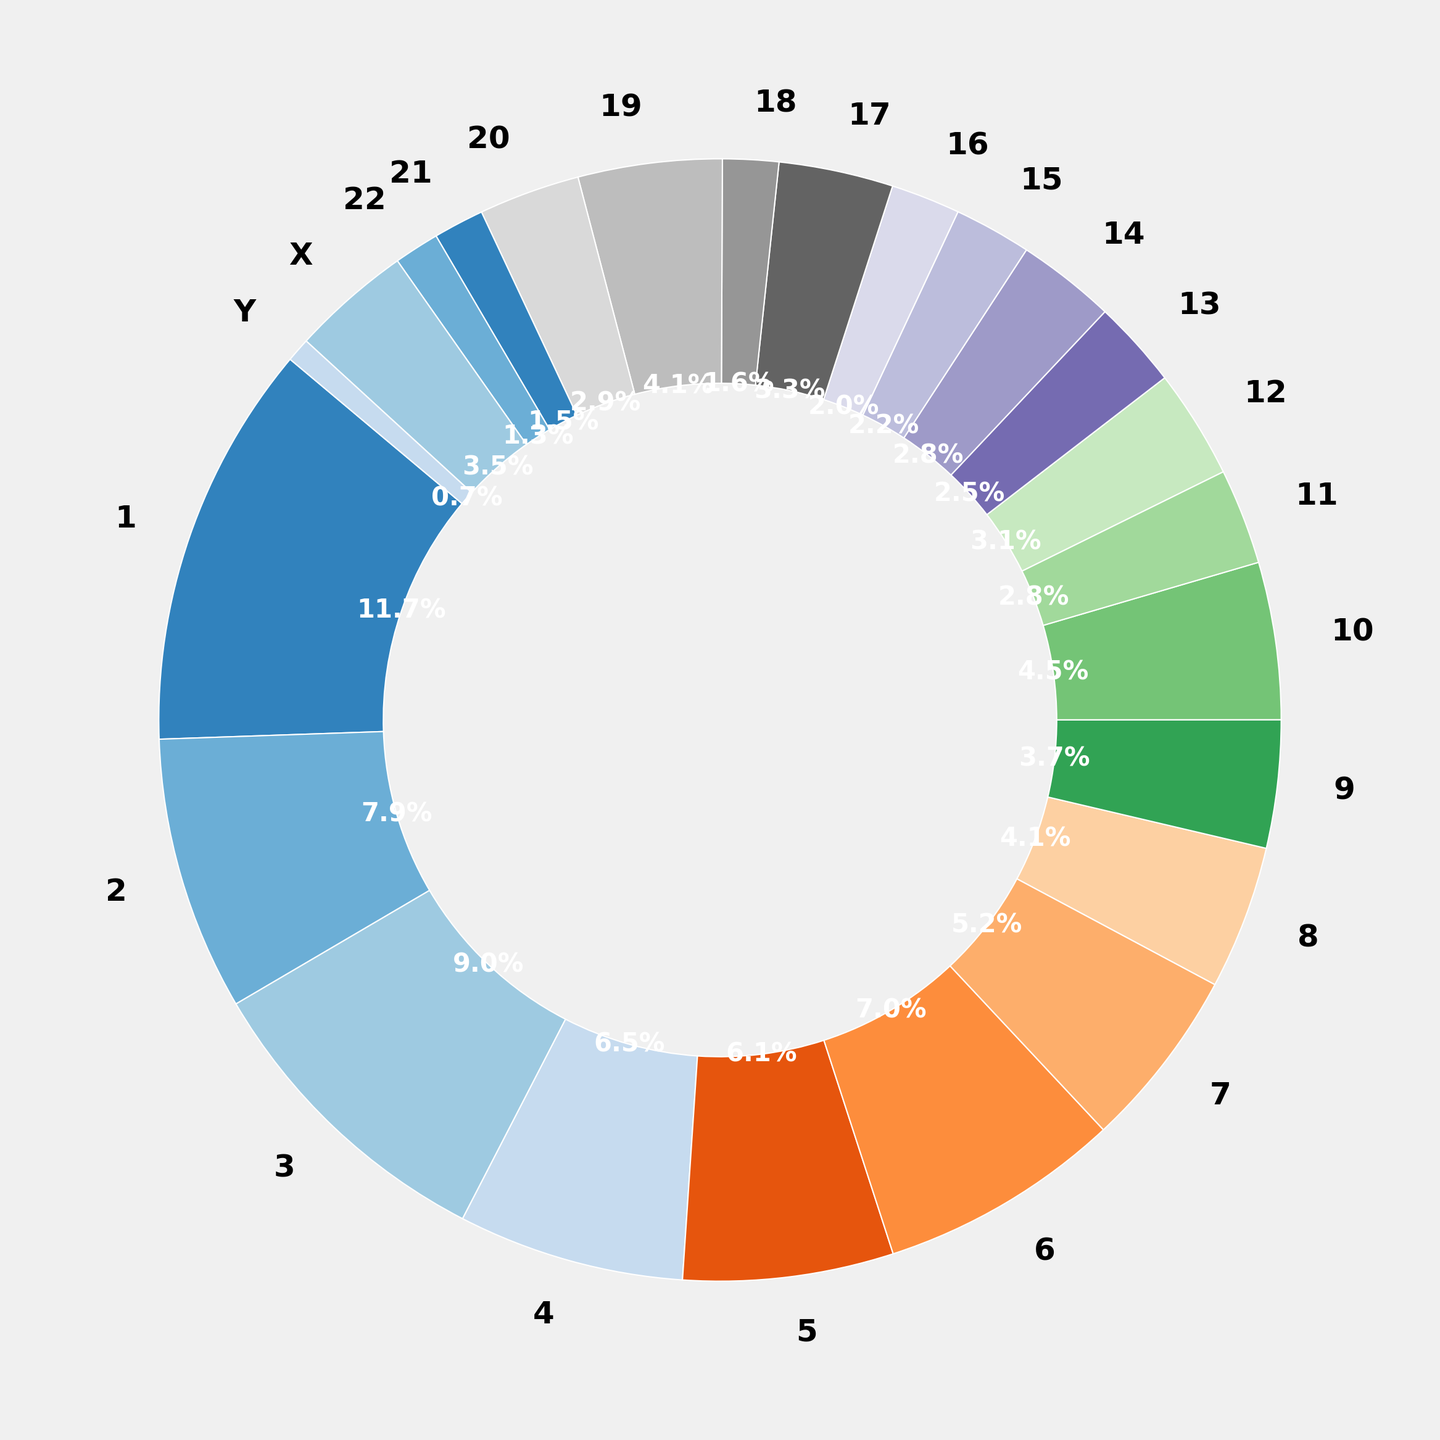Which chromosome has the highest gene expression level? By looking at the pie chart, the slice representing chromosome 1 is the largest.
Answer: Chromosome 1 Which chromosome has the lowest gene expression level? In the pie chart, the smallest slice is for chromosome Y.
Answer: Chromosome Y How many chromosomes have gene expression levels greater than 5%? We need to count the slices with labels showing percentages greater than 5% - specifically chromosomes 1, 2, 3, 4, 6, and 8.
Answer: 6 chromosomes What is the combined gene expression level of chromosomes 10 and 19? Check the labels on the pie chart: chromosome 10 has 5.9%, and chromosome 19 has 5.4%. The combined level is 5.9% + 5.4% = 11.3%.
Answer: 11.3% Are there more autosomal chromosomes with an expression level less than 3% or more than 3%? Count autosomal chromosomes with <3% (15, 16, 18, 21, 22) and >3% (1-14, 17, 19-20). There are 5 chromosomes <3% and 17 chromosomes >3%.
Answer: More chromosomes have gene expression levels greater than 3% What percentage of total gene expression is made up by chromosomes 5, 7, and 8 combined? Add percentages from the pie chart for chromosomes 5 (7.9%), 7 (6.8%), and 8 (5.4%). 7.9% + 6.8% + 5.4% = 20.1%.
Answer: 20.1% Which chromosome, autosomal or XY, has the smallest slice in the pie chart? Chromosome Y has the smallest slice objectively, which is less visible in comparison to others.
Answer: Chromosome Y Compare the gene expression levels of chromosomes 3 and X. Which one is higher? Chromosome 3's label reads 11.7%, and chromosome X's label reads 4.5%. 11.7% is higher than 4.5%.
Answer: Chromosome 3 What is the difference in gene expression levels between chromosome X and chromosome 2? From the chart, chromosome X has 4.5% and chromosome 2 has 10.3%. The difference is 10.3% - 4.5% = 5.8%.
Answer: 5.8% Which chromosomes collectively contribute to more than 50% of the total gene expression? Add the percentages in descending order until exceeding 50%: chromosomes 1 (15.2%), 2 (10.3%), 3 (11.7%), and 4 (8.5%) sum to 45.7%, adding chromosome 5 (7.9%) surpasses 50%. So, 1, 2, 3, 4, and 5 together contribute more than 50%.
Answer: Chromosomes 1, 2, 3, 4, and 5 